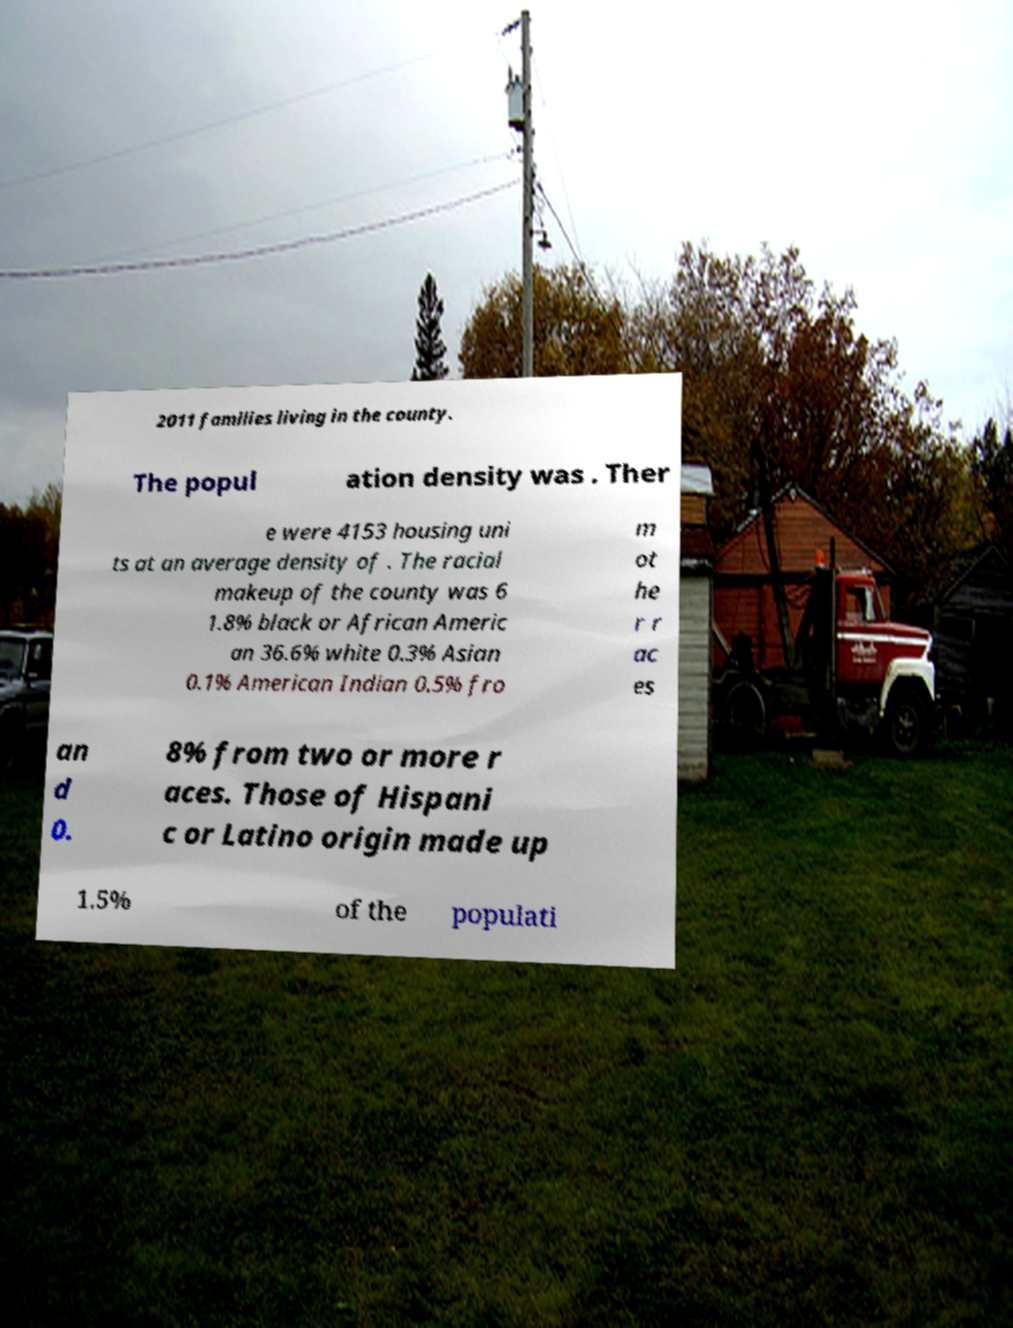Could you extract and type out the text from this image? 2011 families living in the county. The popul ation density was . Ther e were 4153 housing uni ts at an average density of . The racial makeup of the county was 6 1.8% black or African Americ an 36.6% white 0.3% Asian 0.1% American Indian 0.5% fro m ot he r r ac es an d 0. 8% from two or more r aces. Those of Hispani c or Latino origin made up 1.5% of the populati 